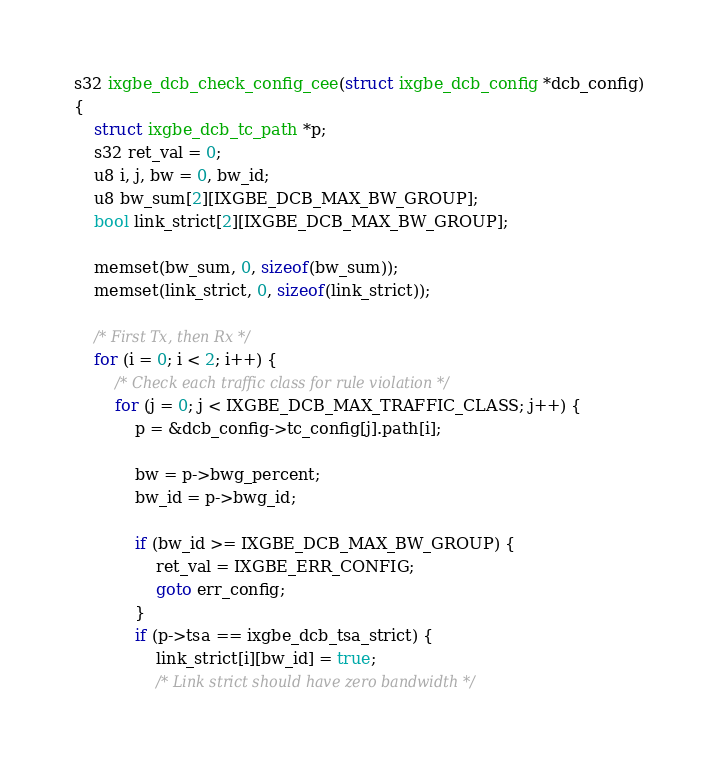Convert code to text. <code><loc_0><loc_0><loc_500><loc_500><_C_>s32 ixgbe_dcb_check_config_cee(struct ixgbe_dcb_config *dcb_config)
{
	struct ixgbe_dcb_tc_path *p;
	s32 ret_val = 0;
	u8 i, j, bw = 0, bw_id;
	u8 bw_sum[2][IXGBE_DCB_MAX_BW_GROUP];
	bool link_strict[2][IXGBE_DCB_MAX_BW_GROUP];

	memset(bw_sum, 0, sizeof(bw_sum));
	memset(link_strict, 0, sizeof(link_strict));

	/* First Tx, then Rx */
	for (i = 0; i < 2; i++) {
		/* Check each traffic class for rule violation */
		for (j = 0; j < IXGBE_DCB_MAX_TRAFFIC_CLASS; j++) {
			p = &dcb_config->tc_config[j].path[i];

			bw = p->bwg_percent;
			bw_id = p->bwg_id;

			if (bw_id >= IXGBE_DCB_MAX_BW_GROUP) {
				ret_val = IXGBE_ERR_CONFIG;
				goto err_config;
			}
			if (p->tsa == ixgbe_dcb_tsa_strict) {
				link_strict[i][bw_id] = true;
				/* Link strict should have zero bandwidth */</code> 